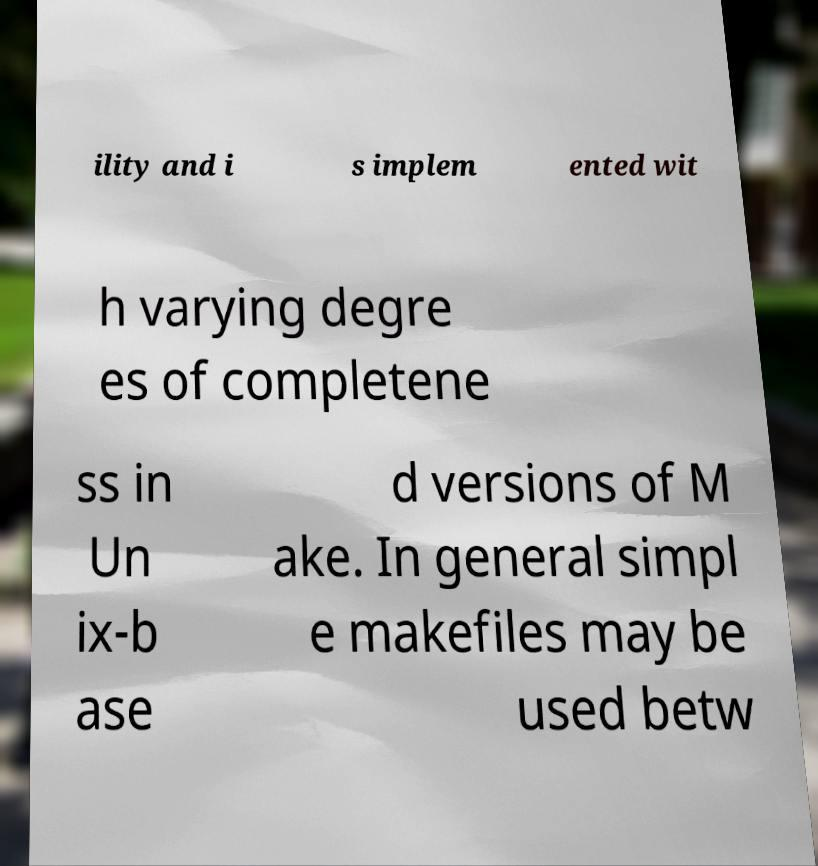Please identify and transcribe the text found in this image. ility and i s implem ented wit h varying degre es of completene ss in Un ix-b ase d versions of M ake. In general simpl e makefiles may be used betw 